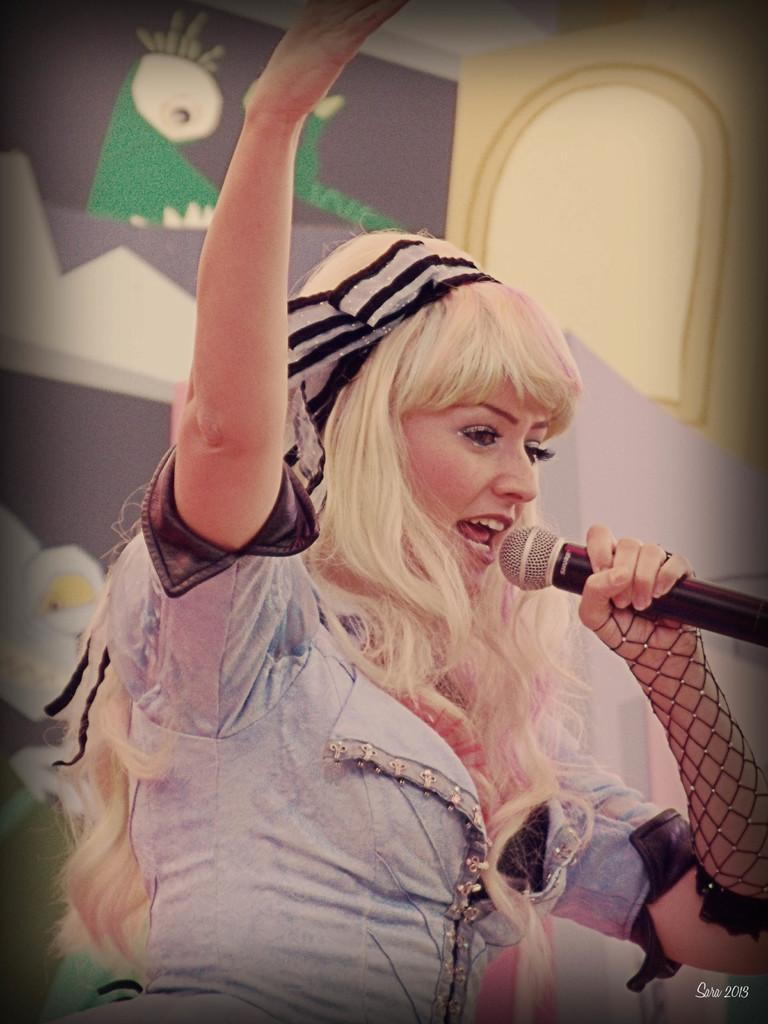Who is the main subject in the image? There is a woman in the image. What is the woman doing in the image? The woman is singing. What object is the woman holding in her hand? The woman is holding a microphone in her hand. Where is the crook hiding in the image? There is no crook present in the image. Can you see a nest in the image? There is no nest present in the image. 